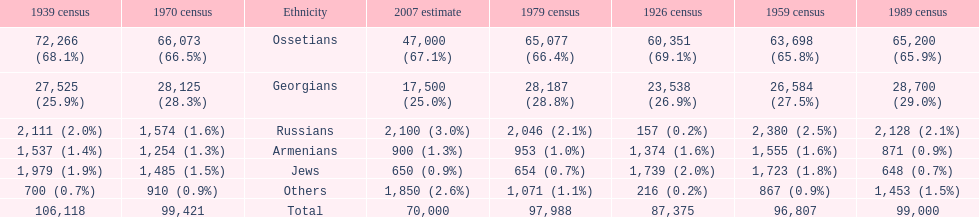Which population had the most people in 1926? Ossetians. 